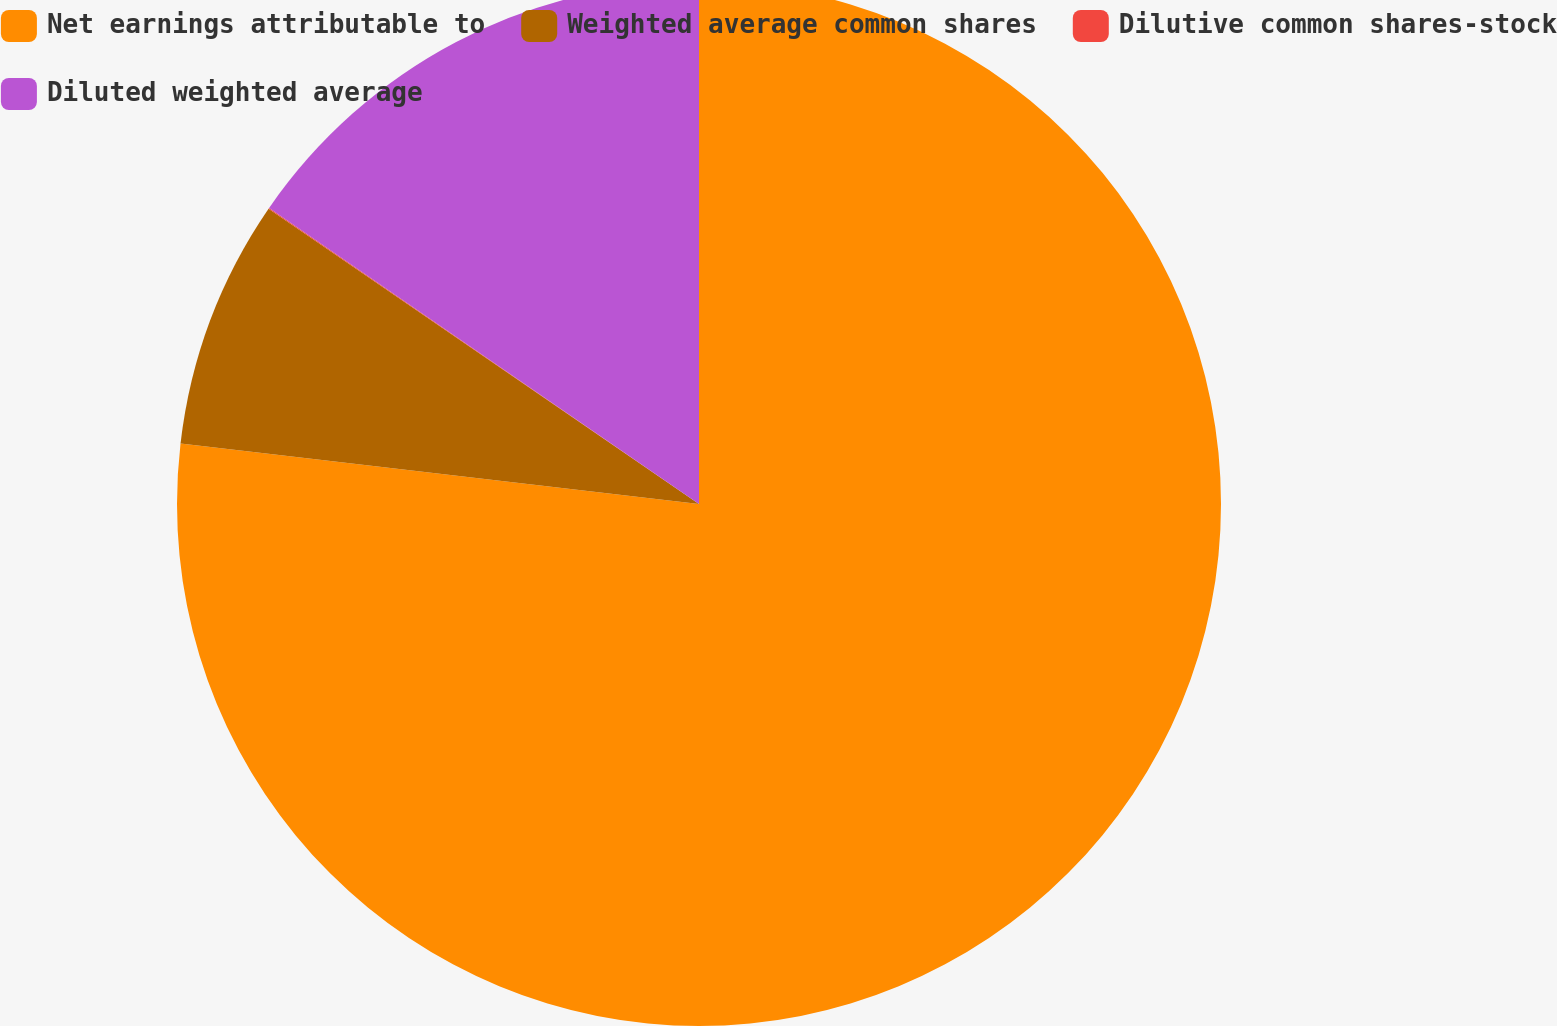<chart> <loc_0><loc_0><loc_500><loc_500><pie_chart><fcel>Net earnings attributable to<fcel>Weighted average common shares<fcel>Dilutive common shares-stock<fcel>Diluted weighted average<nl><fcel>76.85%<fcel>7.72%<fcel>0.03%<fcel>15.4%<nl></chart> 